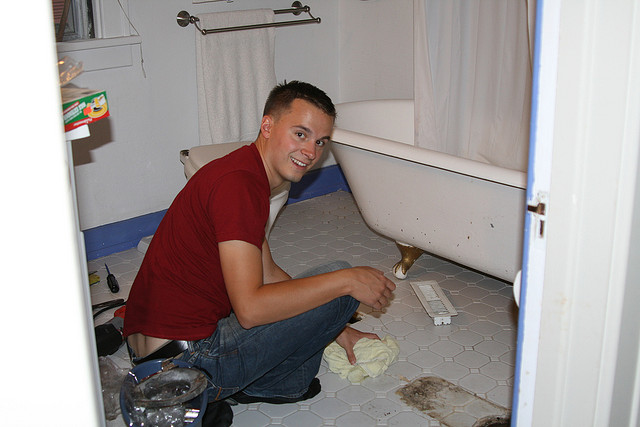What might have happened in this bathroom before this photo was taken? Before this photo was taken, it appears there might have been some repair or maintenance activity happening. The presence of a screwdriver, cleaning cloth, and other tools suggests that the man might have been fixing or installing something, possibly related to the bathtub or the plumbing. Given his smile, it looks like he is satisfied with the progress or the completion of the task. Can you describe a realistic scenario based on this image? In a realistic scenario, this man could have been working on a minor bathroom renovation or cleaning task. Perhaps there was a small leak under the bathtub, and he had to fix it by replacing a part with the help of a screwdriver. After completing the repair, he decided to clean up the floor, which explains the cloth in his hand. The tools and supplies around indicate that this was a planned task, where he needed multiple items to complete his work. 